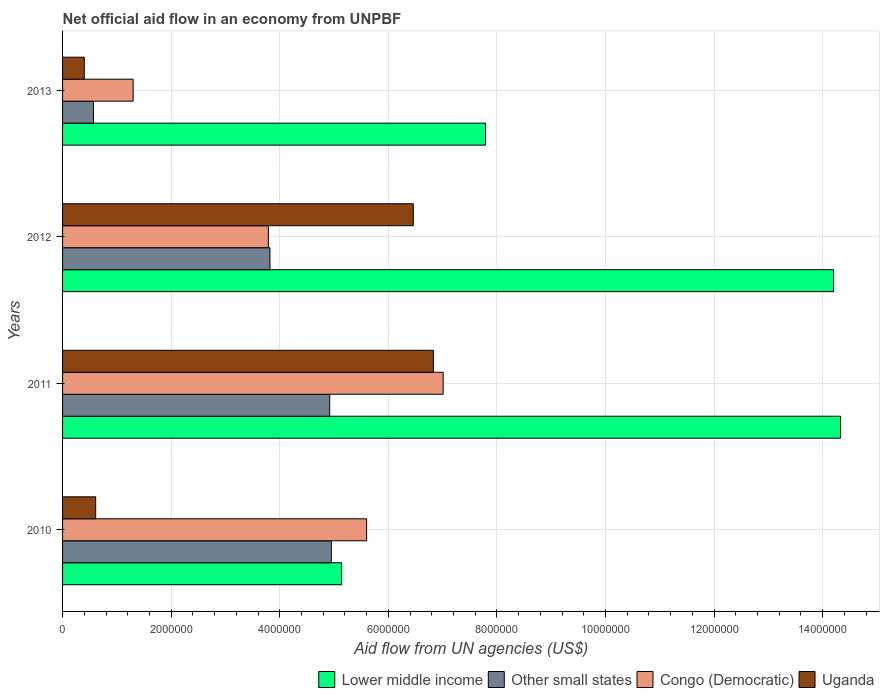Are the number of bars on each tick of the Y-axis equal?
Give a very brief answer. Yes. How many bars are there on the 3rd tick from the top?
Ensure brevity in your answer.  4. How many bars are there on the 2nd tick from the bottom?
Make the answer very short. 4. What is the label of the 2nd group of bars from the top?
Keep it short and to the point. 2012. In how many cases, is the number of bars for a given year not equal to the number of legend labels?
Make the answer very short. 0. What is the net official aid flow in Congo (Democratic) in 2012?
Make the answer very short. 3.79e+06. Across all years, what is the maximum net official aid flow in Other small states?
Provide a succinct answer. 4.95e+06. Across all years, what is the minimum net official aid flow in Uganda?
Give a very brief answer. 4.00e+05. In which year was the net official aid flow in Other small states maximum?
Provide a succinct answer. 2010. In which year was the net official aid flow in Lower middle income minimum?
Your response must be concise. 2010. What is the total net official aid flow in Congo (Democratic) in the graph?
Give a very brief answer. 1.77e+07. What is the difference between the net official aid flow in Congo (Democratic) in 2011 and that in 2012?
Your answer should be compact. 3.22e+06. What is the difference between the net official aid flow in Congo (Democratic) in 2010 and the net official aid flow in Lower middle income in 2011?
Provide a succinct answer. -8.73e+06. What is the average net official aid flow in Uganda per year?
Your answer should be compact. 3.58e+06. In the year 2010, what is the difference between the net official aid flow in Lower middle income and net official aid flow in Congo (Democratic)?
Your answer should be compact. -4.60e+05. What is the ratio of the net official aid flow in Lower middle income in 2011 to that in 2013?
Keep it short and to the point. 1.84. Is the net official aid flow in Other small states in 2012 less than that in 2013?
Your answer should be compact. No. Is the difference between the net official aid flow in Lower middle income in 2010 and 2013 greater than the difference between the net official aid flow in Congo (Democratic) in 2010 and 2013?
Offer a very short reply. No. What is the difference between the highest and the second highest net official aid flow in Congo (Democratic)?
Your answer should be compact. 1.41e+06. What is the difference between the highest and the lowest net official aid flow in Uganda?
Offer a terse response. 6.43e+06. In how many years, is the net official aid flow in Other small states greater than the average net official aid flow in Other small states taken over all years?
Your answer should be compact. 3. What does the 3rd bar from the top in 2012 represents?
Provide a short and direct response. Other small states. What does the 2nd bar from the bottom in 2013 represents?
Your answer should be compact. Other small states. Is it the case that in every year, the sum of the net official aid flow in Uganda and net official aid flow in Lower middle income is greater than the net official aid flow in Other small states?
Your answer should be very brief. Yes. How many years are there in the graph?
Your answer should be compact. 4. What is the difference between two consecutive major ticks on the X-axis?
Make the answer very short. 2.00e+06. Does the graph contain any zero values?
Your answer should be very brief. No. Does the graph contain grids?
Make the answer very short. Yes. Where does the legend appear in the graph?
Make the answer very short. Bottom right. How many legend labels are there?
Your response must be concise. 4. How are the legend labels stacked?
Offer a terse response. Horizontal. What is the title of the graph?
Your response must be concise. Net official aid flow in an economy from UNPBF. What is the label or title of the X-axis?
Offer a very short reply. Aid flow from UN agencies (US$). What is the Aid flow from UN agencies (US$) in Lower middle income in 2010?
Provide a short and direct response. 5.14e+06. What is the Aid flow from UN agencies (US$) of Other small states in 2010?
Give a very brief answer. 4.95e+06. What is the Aid flow from UN agencies (US$) of Congo (Democratic) in 2010?
Offer a very short reply. 5.60e+06. What is the Aid flow from UN agencies (US$) in Uganda in 2010?
Your response must be concise. 6.10e+05. What is the Aid flow from UN agencies (US$) in Lower middle income in 2011?
Your answer should be compact. 1.43e+07. What is the Aid flow from UN agencies (US$) in Other small states in 2011?
Ensure brevity in your answer.  4.92e+06. What is the Aid flow from UN agencies (US$) of Congo (Democratic) in 2011?
Provide a short and direct response. 7.01e+06. What is the Aid flow from UN agencies (US$) in Uganda in 2011?
Give a very brief answer. 6.83e+06. What is the Aid flow from UN agencies (US$) of Lower middle income in 2012?
Give a very brief answer. 1.42e+07. What is the Aid flow from UN agencies (US$) of Other small states in 2012?
Keep it short and to the point. 3.82e+06. What is the Aid flow from UN agencies (US$) in Congo (Democratic) in 2012?
Keep it short and to the point. 3.79e+06. What is the Aid flow from UN agencies (US$) of Uganda in 2012?
Ensure brevity in your answer.  6.46e+06. What is the Aid flow from UN agencies (US$) of Lower middle income in 2013?
Your response must be concise. 7.79e+06. What is the Aid flow from UN agencies (US$) in Other small states in 2013?
Offer a terse response. 5.70e+05. What is the Aid flow from UN agencies (US$) of Congo (Democratic) in 2013?
Offer a very short reply. 1.30e+06. What is the Aid flow from UN agencies (US$) in Uganda in 2013?
Provide a succinct answer. 4.00e+05. Across all years, what is the maximum Aid flow from UN agencies (US$) in Lower middle income?
Offer a very short reply. 1.43e+07. Across all years, what is the maximum Aid flow from UN agencies (US$) in Other small states?
Give a very brief answer. 4.95e+06. Across all years, what is the maximum Aid flow from UN agencies (US$) in Congo (Democratic)?
Provide a succinct answer. 7.01e+06. Across all years, what is the maximum Aid flow from UN agencies (US$) in Uganda?
Keep it short and to the point. 6.83e+06. Across all years, what is the minimum Aid flow from UN agencies (US$) of Lower middle income?
Keep it short and to the point. 5.14e+06. Across all years, what is the minimum Aid flow from UN agencies (US$) in Other small states?
Provide a short and direct response. 5.70e+05. Across all years, what is the minimum Aid flow from UN agencies (US$) of Congo (Democratic)?
Your response must be concise. 1.30e+06. Across all years, what is the minimum Aid flow from UN agencies (US$) in Uganda?
Your answer should be compact. 4.00e+05. What is the total Aid flow from UN agencies (US$) in Lower middle income in the graph?
Your answer should be very brief. 4.15e+07. What is the total Aid flow from UN agencies (US$) in Other small states in the graph?
Your answer should be very brief. 1.43e+07. What is the total Aid flow from UN agencies (US$) of Congo (Democratic) in the graph?
Make the answer very short. 1.77e+07. What is the total Aid flow from UN agencies (US$) of Uganda in the graph?
Keep it short and to the point. 1.43e+07. What is the difference between the Aid flow from UN agencies (US$) of Lower middle income in 2010 and that in 2011?
Offer a terse response. -9.19e+06. What is the difference between the Aid flow from UN agencies (US$) of Congo (Democratic) in 2010 and that in 2011?
Provide a succinct answer. -1.41e+06. What is the difference between the Aid flow from UN agencies (US$) of Uganda in 2010 and that in 2011?
Provide a short and direct response. -6.22e+06. What is the difference between the Aid flow from UN agencies (US$) in Lower middle income in 2010 and that in 2012?
Your answer should be very brief. -9.06e+06. What is the difference between the Aid flow from UN agencies (US$) in Other small states in 2010 and that in 2012?
Your answer should be compact. 1.13e+06. What is the difference between the Aid flow from UN agencies (US$) in Congo (Democratic) in 2010 and that in 2012?
Your answer should be compact. 1.81e+06. What is the difference between the Aid flow from UN agencies (US$) of Uganda in 2010 and that in 2012?
Provide a succinct answer. -5.85e+06. What is the difference between the Aid flow from UN agencies (US$) in Lower middle income in 2010 and that in 2013?
Offer a terse response. -2.65e+06. What is the difference between the Aid flow from UN agencies (US$) of Other small states in 2010 and that in 2013?
Give a very brief answer. 4.38e+06. What is the difference between the Aid flow from UN agencies (US$) of Congo (Democratic) in 2010 and that in 2013?
Give a very brief answer. 4.30e+06. What is the difference between the Aid flow from UN agencies (US$) of Uganda in 2010 and that in 2013?
Ensure brevity in your answer.  2.10e+05. What is the difference between the Aid flow from UN agencies (US$) in Other small states in 2011 and that in 2012?
Offer a terse response. 1.10e+06. What is the difference between the Aid flow from UN agencies (US$) of Congo (Democratic) in 2011 and that in 2012?
Provide a succinct answer. 3.22e+06. What is the difference between the Aid flow from UN agencies (US$) of Lower middle income in 2011 and that in 2013?
Ensure brevity in your answer.  6.54e+06. What is the difference between the Aid flow from UN agencies (US$) of Other small states in 2011 and that in 2013?
Offer a terse response. 4.35e+06. What is the difference between the Aid flow from UN agencies (US$) of Congo (Democratic) in 2011 and that in 2013?
Give a very brief answer. 5.71e+06. What is the difference between the Aid flow from UN agencies (US$) of Uganda in 2011 and that in 2013?
Give a very brief answer. 6.43e+06. What is the difference between the Aid flow from UN agencies (US$) in Lower middle income in 2012 and that in 2013?
Your answer should be very brief. 6.41e+06. What is the difference between the Aid flow from UN agencies (US$) in Other small states in 2012 and that in 2013?
Offer a very short reply. 3.25e+06. What is the difference between the Aid flow from UN agencies (US$) of Congo (Democratic) in 2012 and that in 2013?
Give a very brief answer. 2.49e+06. What is the difference between the Aid flow from UN agencies (US$) of Uganda in 2012 and that in 2013?
Offer a very short reply. 6.06e+06. What is the difference between the Aid flow from UN agencies (US$) of Lower middle income in 2010 and the Aid flow from UN agencies (US$) of Other small states in 2011?
Make the answer very short. 2.20e+05. What is the difference between the Aid flow from UN agencies (US$) of Lower middle income in 2010 and the Aid flow from UN agencies (US$) of Congo (Democratic) in 2011?
Ensure brevity in your answer.  -1.87e+06. What is the difference between the Aid flow from UN agencies (US$) in Lower middle income in 2010 and the Aid flow from UN agencies (US$) in Uganda in 2011?
Make the answer very short. -1.69e+06. What is the difference between the Aid flow from UN agencies (US$) of Other small states in 2010 and the Aid flow from UN agencies (US$) of Congo (Democratic) in 2011?
Give a very brief answer. -2.06e+06. What is the difference between the Aid flow from UN agencies (US$) of Other small states in 2010 and the Aid flow from UN agencies (US$) of Uganda in 2011?
Ensure brevity in your answer.  -1.88e+06. What is the difference between the Aid flow from UN agencies (US$) in Congo (Democratic) in 2010 and the Aid flow from UN agencies (US$) in Uganda in 2011?
Give a very brief answer. -1.23e+06. What is the difference between the Aid flow from UN agencies (US$) of Lower middle income in 2010 and the Aid flow from UN agencies (US$) of Other small states in 2012?
Ensure brevity in your answer.  1.32e+06. What is the difference between the Aid flow from UN agencies (US$) of Lower middle income in 2010 and the Aid flow from UN agencies (US$) of Congo (Democratic) in 2012?
Give a very brief answer. 1.35e+06. What is the difference between the Aid flow from UN agencies (US$) of Lower middle income in 2010 and the Aid flow from UN agencies (US$) of Uganda in 2012?
Ensure brevity in your answer.  -1.32e+06. What is the difference between the Aid flow from UN agencies (US$) of Other small states in 2010 and the Aid flow from UN agencies (US$) of Congo (Democratic) in 2012?
Your response must be concise. 1.16e+06. What is the difference between the Aid flow from UN agencies (US$) of Other small states in 2010 and the Aid flow from UN agencies (US$) of Uganda in 2012?
Ensure brevity in your answer.  -1.51e+06. What is the difference between the Aid flow from UN agencies (US$) of Congo (Democratic) in 2010 and the Aid flow from UN agencies (US$) of Uganda in 2012?
Your response must be concise. -8.60e+05. What is the difference between the Aid flow from UN agencies (US$) of Lower middle income in 2010 and the Aid flow from UN agencies (US$) of Other small states in 2013?
Offer a very short reply. 4.57e+06. What is the difference between the Aid flow from UN agencies (US$) of Lower middle income in 2010 and the Aid flow from UN agencies (US$) of Congo (Democratic) in 2013?
Keep it short and to the point. 3.84e+06. What is the difference between the Aid flow from UN agencies (US$) in Lower middle income in 2010 and the Aid flow from UN agencies (US$) in Uganda in 2013?
Ensure brevity in your answer.  4.74e+06. What is the difference between the Aid flow from UN agencies (US$) in Other small states in 2010 and the Aid flow from UN agencies (US$) in Congo (Democratic) in 2013?
Offer a very short reply. 3.65e+06. What is the difference between the Aid flow from UN agencies (US$) of Other small states in 2010 and the Aid flow from UN agencies (US$) of Uganda in 2013?
Provide a short and direct response. 4.55e+06. What is the difference between the Aid flow from UN agencies (US$) of Congo (Democratic) in 2010 and the Aid flow from UN agencies (US$) of Uganda in 2013?
Offer a very short reply. 5.20e+06. What is the difference between the Aid flow from UN agencies (US$) in Lower middle income in 2011 and the Aid flow from UN agencies (US$) in Other small states in 2012?
Make the answer very short. 1.05e+07. What is the difference between the Aid flow from UN agencies (US$) of Lower middle income in 2011 and the Aid flow from UN agencies (US$) of Congo (Democratic) in 2012?
Give a very brief answer. 1.05e+07. What is the difference between the Aid flow from UN agencies (US$) of Lower middle income in 2011 and the Aid flow from UN agencies (US$) of Uganda in 2012?
Make the answer very short. 7.87e+06. What is the difference between the Aid flow from UN agencies (US$) of Other small states in 2011 and the Aid flow from UN agencies (US$) of Congo (Democratic) in 2012?
Offer a very short reply. 1.13e+06. What is the difference between the Aid flow from UN agencies (US$) in Other small states in 2011 and the Aid flow from UN agencies (US$) in Uganda in 2012?
Provide a succinct answer. -1.54e+06. What is the difference between the Aid flow from UN agencies (US$) in Lower middle income in 2011 and the Aid flow from UN agencies (US$) in Other small states in 2013?
Offer a very short reply. 1.38e+07. What is the difference between the Aid flow from UN agencies (US$) of Lower middle income in 2011 and the Aid flow from UN agencies (US$) of Congo (Democratic) in 2013?
Keep it short and to the point. 1.30e+07. What is the difference between the Aid flow from UN agencies (US$) in Lower middle income in 2011 and the Aid flow from UN agencies (US$) in Uganda in 2013?
Offer a very short reply. 1.39e+07. What is the difference between the Aid flow from UN agencies (US$) of Other small states in 2011 and the Aid flow from UN agencies (US$) of Congo (Democratic) in 2013?
Offer a very short reply. 3.62e+06. What is the difference between the Aid flow from UN agencies (US$) in Other small states in 2011 and the Aid flow from UN agencies (US$) in Uganda in 2013?
Your response must be concise. 4.52e+06. What is the difference between the Aid flow from UN agencies (US$) in Congo (Democratic) in 2011 and the Aid flow from UN agencies (US$) in Uganda in 2013?
Offer a very short reply. 6.61e+06. What is the difference between the Aid flow from UN agencies (US$) of Lower middle income in 2012 and the Aid flow from UN agencies (US$) of Other small states in 2013?
Keep it short and to the point. 1.36e+07. What is the difference between the Aid flow from UN agencies (US$) in Lower middle income in 2012 and the Aid flow from UN agencies (US$) in Congo (Democratic) in 2013?
Keep it short and to the point. 1.29e+07. What is the difference between the Aid flow from UN agencies (US$) in Lower middle income in 2012 and the Aid flow from UN agencies (US$) in Uganda in 2013?
Offer a very short reply. 1.38e+07. What is the difference between the Aid flow from UN agencies (US$) in Other small states in 2012 and the Aid flow from UN agencies (US$) in Congo (Democratic) in 2013?
Offer a terse response. 2.52e+06. What is the difference between the Aid flow from UN agencies (US$) of Other small states in 2012 and the Aid flow from UN agencies (US$) of Uganda in 2013?
Offer a terse response. 3.42e+06. What is the difference between the Aid flow from UN agencies (US$) in Congo (Democratic) in 2012 and the Aid flow from UN agencies (US$) in Uganda in 2013?
Your answer should be compact. 3.39e+06. What is the average Aid flow from UN agencies (US$) in Lower middle income per year?
Offer a terse response. 1.04e+07. What is the average Aid flow from UN agencies (US$) in Other small states per year?
Your response must be concise. 3.56e+06. What is the average Aid flow from UN agencies (US$) in Congo (Democratic) per year?
Offer a terse response. 4.42e+06. What is the average Aid flow from UN agencies (US$) of Uganda per year?
Provide a succinct answer. 3.58e+06. In the year 2010, what is the difference between the Aid flow from UN agencies (US$) in Lower middle income and Aid flow from UN agencies (US$) in Congo (Democratic)?
Your response must be concise. -4.60e+05. In the year 2010, what is the difference between the Aid flow from UN agencies (US$) in Lower middle income and Aid flow from UN agencies (US$) in Uganda?
Offer a very short reply. 4.53e+06. In the year 2010, what is the difference between the Aid flow from UN agencies (US$) of Other small states and Aid flow from UN agencies (US$) of Congo (Democratic)?
Give a very brief answer. -6.50e+05. In the year 2010, what is the difference between the Aid flow from UN agencies (US$) of Other small states and Aid flow from UN agencies (US$) of Uganda?
Provide a succinct answer. 4.34e+06. In the year 2010, what is the difference between the Aid flow from UN agencies (US$) of Congo (Democratic) and Aid flow from UN agencies (US$) of Uganda?
Give a very brief answer. 4.99e+06. In the year 2011, what is the difference between the Aid flow from UN agencies (US$) in Lower middle income and Aid flow from UN agencies (US$) in Other small states?
Give a very brief answer. 9.41e+06. In the year 2011, what is the difference between the Aid flow from UN agencies (US$) in Lower middle income and Aid flow from UN agencies (US$) in Congo (Democratic)?
Ensure brevity in your answer.  7.32e+06. In the year 2011, what is the difference between the Aid flow from UN agencies (US$) in Lower middle income and Aid flow from UN agencies (US$) in Uganda?
Give a very brief answer. 7.50e+06. In the year 2011, what is the difference between the Aid flow from UN agencies (US$) in Other small states and Aid flow from UN agencies (US$) in Congo (Democratic)?
Offer a terse response. -2.09e+06. In the year 2011, what is the difference between the Aid flow from UN agencies (US$) of Other small states and Aid flow from UN agencies (US$) of Uganda?
Give a very brief answer. -1.91e+06. In the year 2012, what is the difference between the Aid flow from UN agencies (US$) of Lower middle income and Aid flow from UN agencies (US$) of Other small states?
Your response must be concise. 1.04e+07. In the year 2012, what is the difference between the Aid flow from UN agencies (US$) in Lower middle income and Aid flow from UN agencies (US$) in Congo (Democratic)?
Offer a terse response. 1.04e+07. In the year 2012, what is the difference between the Aid flow from UN agencies (US$) in Lower middle income and Aid flow from UN agencies (US$) in Uganda?
Offer a terse response. 7.74e+06. In the year 2012, what is the difference between the Aid flow from UN agencies (US$) in Other small states and Aid flow from UN agencies (US$) in Congo (Democratic)?
Make the answer very short. 3.00e+04. In the year 2012, what is the difference between the Aid flow from UN agencies (US$) in Other small states and Aid flow from UN agencies (US$) in Uganda?
Provide a succinct answer. -2.64e+06. In the year 2012, what is the difference between the Aid flow from UN agencies (US$) of Congo (Democratic) and Aid flow from UN agencies (US$) of Uganda?
Provide a succinct answer. -2.67e+06. In the year 2013, what is the difference between the Aid flow from UN agencies (US$) of Lower middle income and Aid flow from UN agencies (US$) of Other small states?
Provide a short and direct response. 7.22e+06. In the year 2013, what is the difference between the Aid flow from UN agencies (US$) in Lower middle income and Aid flow from UN agencies (US$) in Congo (Democratic)?
Give a very brief answer. 6.49e+06. In the year 2013, what is the difference between the Aid flow from UN agencies (US$) in Lower middle income and Aid flow from UN agencies (US$) in Uganda?
Offer a very short reply. 7.39e+06. In the year 2013, what is the difference between the Aid flow from UN agencies (US$) in Other small states and Aid flow from UN agencies (US$) in Congo (Democratic)?
Keep it short and to the point. -7.30e+05. What is the ratio of the Aid flow from UN agencies (US$) of Lower middle income in 2010 to that in 2011?
Offer a very short reply. 0.36. What is the ratio of the Aid flow from UN agencies (US$) of Other small states in 2010 to that in 2011?
Provide a short and direct response. 1.01. What is the ratio of the Aid flow from UN agencies (US$) in Congo (Democratic) in 2010 to that in 2011?
Your answer should be compact. 0.8. What is the ratio of the Aid flow from UN agencies (US$) in Uganda in 2010 to that in 2011?
Offer a terse response. 0.09. What is the ratio of the Aid flow from UN agencies (US$) in Lower middle income in 2010 to that in 2012?
Your response must be concise. 0.36. What is the ratio of the Aid flow from UN agencies (US$) of Other small states in 2010 to that in 2012?
Provide a short and direct response. 1.3. What is the ratio of the Aid flow from UN agencies (US$) of Congo (Democratic) in 2010 to that in 2012?
Your answer should be compact. 1.48. What is the ratio of the Aid flow from UN agencies (US$) of Uganda in 2010 to that in 2012?
Keep it short and to the point. 0.09. What is the ratio of the Aid flow from UN agencies (US$) in Lower middle income in 2010 to that in 2013?
Provide a succinct answer. 0.66. What is the ratio of the Aid flow from UN agencies (US$) in Other small states in 2010 to that in 2013?
Offer a very short reply. 8.68. What is the ratio of the Aid flow from UN agencies (US$) in Congo (Democratic) in 2010 to that in 2013?
Provide a short and direct response. 4.31. What is the ratio of the Aid flow from UN agencies (US$) of Uganda in 2010 to that in 2013?
Make the answer very short. 1.52. What is the ratio of the Aid flow from UN agencies (US$) in Lower middle income in 2011 to that in 2012?
Ensure brevity in your answer.  1.01. What is the ratio of the Aid flow from UN agencies (US$) of Other small states in 2011 to that in 2012?
Offer a very short reply. 1.29. What is the ratio of the Aid flow from UN agencies (US$) in Congo (Democratic) in 2011 to that in 2012?
Your answer should be compact. 1.85. What is the ratio of the Aid flow from UN agencies (US$) of Uganda in 2011 to that in 2012?
Ensure brevity in your answer.  1.06. What is the ratio of the Aid flow from UN agencies (US$) of Lower middle income in 2011 to that in 2013?
Ensure brevity in your answer.  1.84. What is the ratio of the Aid flow from UN agencies (US$) of Other small states in 2011 to that in 2013?
Your answer should be very brief. 8.63. What is the ratio of the Aid flow from UN agencies (US$) of Congo (Democratic) in 2011 to that in 2013?
Give a very brief answer. 5.39. What is the ratio of the Aid flow from UN agencies (US$) of Uganda in 2011 to that in 2013?
Your answer should be very brief. 17.07. What is the ratio of the Aid flow from UN agencies (US$) of Lower middle income in 2012 to that in 2013?
Provide a short and direct response. 1.82. What is the ratio of the Aid flow from UN agencies (US$) in Other small states in 2012 to that in 2013?
Your answer should be very brief. 6.7. What is the ratio of the Aid flow from UN agencies (US$) in Congo (Democratic) in 2012 to that in 2013?
Make the answer very short. 2.92. What is the ratio of the Aid flow from UN agencies (US$) in Uganda in 2012 to that in 2013?
Make the answer very short. 16.15. What is the difference between the highest and the second highest Aid flow from UN agencies (US$) in Congo (Democratic)?
Provide a short and direct response. 1.41e+06. What is the difference between the highest and the second highest Aid flow from UN agencies (US$) in Uganda?
Make the answer very short. 3.70e+05. What is the difference between the highest and the lowest Aid flow from UN agencies (US$) of Lower middle income?
Offer a very short reply. 9.19e+06. What is the difference between the highest and the lowest Aid flow from UN agencies (US$) of Other small states?
Keep it short and to the point. 4.38e+06. What is the difference between the highest and the lowest Aid flow from UN agencies (US$) of Congo (Democratic)?
Provide a short and direct response. 5.71e+06. What is the difference between the highest and the lowest Aid flow from UN agencies (US$) of Uganda?
Give a very brief answer. 6.43e+06. 